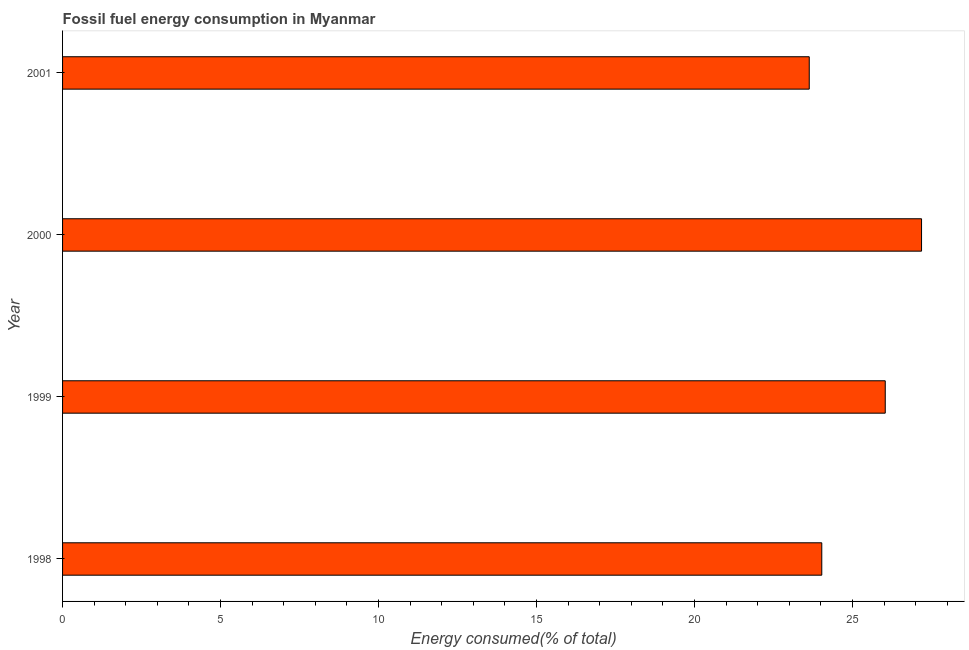Does the graph contain grids?
Your answer should be compact. No. What is the title of the graph?
Offer a very short reply. Fossil fuel energy consumption in Myanmar. What is the label or title of the X-axis?
Give a very brief answer. Energy consumed(% of total). What is the fossil fuel energy consumption in 1998?
Provide a succinct answer. 24.03. Across all years, what is the maximum fossil fuel energy consumption?
Your answer should be compact. 27.18. Across all years, what is the minimum fossil fuel energy consumption?
Give a very brief answer. 23.63. In which year was the fossil fuel energy consumption maximum?
Keep it short and to the point. 2000. What is the sum of the fossil fuel energy consumption?
Make the answer very short. 100.87. What is the difference between the fossil fuel energy consumption in 1998 and 2001?
Your answer should be compact. 0.4. What is the average fossil fuel energy consumption per year?
Offer a terse response. 25.22. What is the median fossil fuel energy consumption?
Keep it short and to the point. 25.03. Do a majority of the years between 1999 and 2001 (inclusive) have fossil fuel energy consumption greater than 27 %?
Give a very brief answer. No. What is the ratio of the fossil fuel energy consumption in 1999 to that in 2001?
Your response must be concise. 1.1. What is the difference between the highest and the second highest fossil fuel energy consumption?
Keep it short and to the point. 1.15. Is the sum of the fossil fuel energy consumption in 1999 and 2001 greater than the maximum fossil fuel energy consumption across all years?
Offer a very short reply. Yes. What is the difference between the highest and the lowest fossil fuel energy consumption?
Your response must be concise. 3.55. In how many years, is the fossil fuel energy consumption greater than the average fossil fuel energy consumption taken over all years?
Provide a succinct answer. 2. Are all the bars in the graph horizontal?
Give a very brief answer. Yes. How many years are there in the graph?
Your answer should be very brief. 4. Are the values on the major ticks of X-axis written in scientific E-notation?
Ensure brevity in your answer.  No. What is the Energy consumed(% of total) in 1998?
Ensure brevity in your answer.  24.03. What is the Energy consumed(% of total) of 1999?
Provide a succinct answer. 26.03. What is the Energy consumed(% of total) of 2000?
Give a very brief answer. 27.18. What is the Energy consumed(% of total) in 2001?
Your response must be concise. 23.63. What is the difference between the Energy consumed(% of total) in 1998 and 1999?
Give a very brief answer. -2.01. What is the difference between the Energy consumed(% of total) in 1998 and 2000?
Offer a terse response. -3.16. What is the difference between the Energy consumed(% of total) in 1998 and 2001?
Your answer should be compact. 0.4. What is the difference between the Energy consumed(% of total) in 1999 and 2000?
Ensure brevity in your answer.  -1.15. What is the difference between the Energy consumed(% of total) in 1999 and 2001?
Keep it short and to the point. 2.4. What is the difference between the Energy consumed(% of total) in 2000 and 2001?
Make the answer very short. 3.55. What is the ratio of the Energy consumed(% of total) in 1998 to that in 1999?
Offer a terse response. 0.92. What is the ratio of the Energy consumed(% of total) in 1998 to that in 2000?
Provide a short and direct response. 0.88. What is the ratio of the Energy consumed(% of total) in 1998 to that in 2001?
Your answer should be compact. 1.02. What is the ratio of the Energy consumed(% of total) in 1999 to that in 2000?
Keep it short and to the point. 0.96. What is the ratio of the Energy consumed(% of total) in 1999 to that in 2001?
Provide a succinct answer. 1.1. What is the ratio of the Energy consumed(% of total) in 2000 to that in 2001?
Your response must be concise. 1.15. 